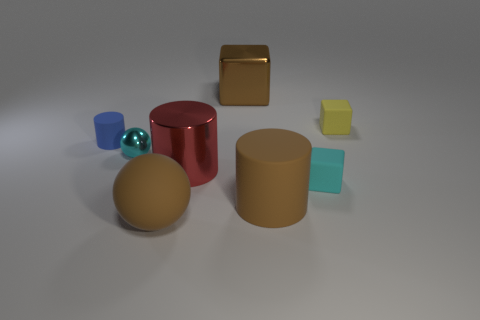Add 1 brown blocks. How many objects exist? 9 Subtract all cylinders. How many objects are left? 5 Add 6 big matte cylinders. How many big matte cylinders are left? 7 Add 1 big red cylinders. How many big red cylinders exist? 2 Subtract 1 yellow cubes. How many objects are left? 7 Subtract all big red cylinders. Subtract all small things. How many objects are left? 3 